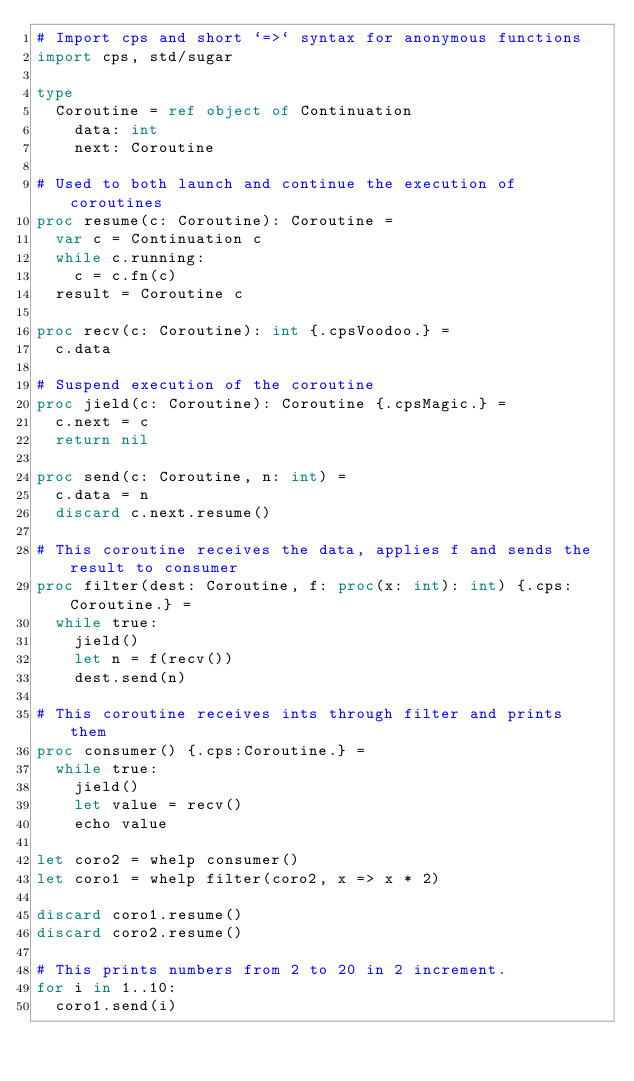<code> <loc_0><loc_0><loc_500><loc_500><_Nim_># Import cps and short `=>` syntax for anonymous functions
import cps, std/sugar

type
  Coroutine = ref object of Continuation
    data: int
    next: Coroutine

# Used to both launch and continue the execution of coroutines
proc resume(c: Coroutine): Coroutine =
  var c = Continuation c
  while c.running:
    c = c.fn(c)
  result = Coroutine c

proc recv(c: Coroutine): int {.cpsVoodoo.} =
  c.data

# Suspend execution of the coroutine
proc jield(c: Coroutine): Coroutine {.cpsMagic.} =
  c.next = c
  return nil

proc send(c: Coroutine, n: int) =
  c.data = n
  discard c.next.resume()

# This coroutine receives the data, applies f and sends the result to consumer
proc filter(dest: Coroutine, f: proc(x: int): int) {.cps:Coroutine.} =
  while true:
    jield()
    let n = f(recv())
    dest.send(n)

# This coroutine receives ints through filter and prints them
proc consumer() {.cps:Coroutine.} =
  while true:
    jield()
    let value = recv()
    echo value

let coro2 = whelp consumer()
let coro1 = whelp filter(coro2, x => x * 2)

discard coro1.resume()
discard coro2.resume()

# This prints numbers from 2 to 20 in 2 increment.
for i in 1..10:
  coro1.send(i)
</code> 